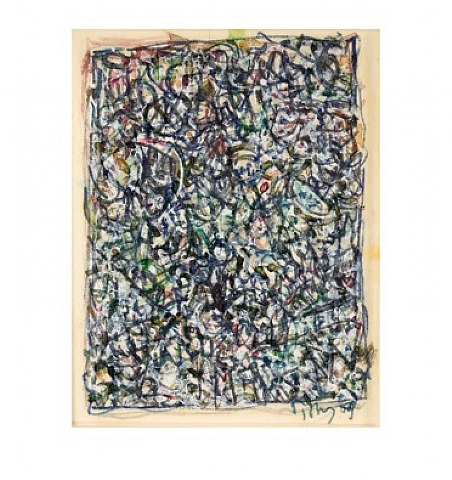Can you tell me more about the emotional impact this painting might have on viewers? The emotional impact of this Jackson Pollock painting can vary significantly from viewer to viewer, reflecting the subjective nature of abstract art. For some, the chaotic interweaving of colors and lines might evoke a sense of energy and dynamism, creating feelings of excitement or even anxiety. The lack of a clear focal point can make the viewer feel overwhelmed, mirroring the complexity and chaos of the modern world.

For others, the painting's complexity and depth might inspire contemplation and introspection, allowing them to lose themselves in the intricate details and find their own patterns or meanings. The vibrant contrasts between colors could invoke joy and optimism, while the darker intertwined sections might elicit a more somber or reflective mood.

In essence, Pollock's art invites viewers to engage with it on a deeply personal level, prompting a diverse range of emotional responses based on their own perceptions, experiences, and feelings. Could you provide a historical context for Pollock's work? Jackson Pollock was a pivotal figure in the abstract expressionist movement, which emerged in the United States during the mid-20th century. This movement was part of a larger post-World War II cultural shift, where many artists sought to break free from traditional artistic conventions and explore new forms of expression.

Pollock's innovative techniques, such as his signature drip painting method, were revolutionary at the time. He would lay his canvas flat on the floor and work from all angles, dripping, splattering, and pouring paint in a seemingly spontaneous manner. This method allowed him to engage physically with his art, creating a direct and intimate connection between the artist and the canvas.

His works were seen as a radical departure from representational art, focusing instead on the act of painting itself as a form of expression. Pollock was influenced by earlier modernist movements such as surrealism, which emphasized the subconscious and the irrational. His work also reflected broader themes of existentialism and the search for meaning in a post-war world.

Despite receiving mixed reactions from critics and the public initially, Pollock's contributions to art were eventually recognized as groundbreaking, cementing his place as a key figure in the history of modern art. His work not only influenced his contemporaries but also paved the way for future generations of artists to explore new and innovative approaches to creation. 